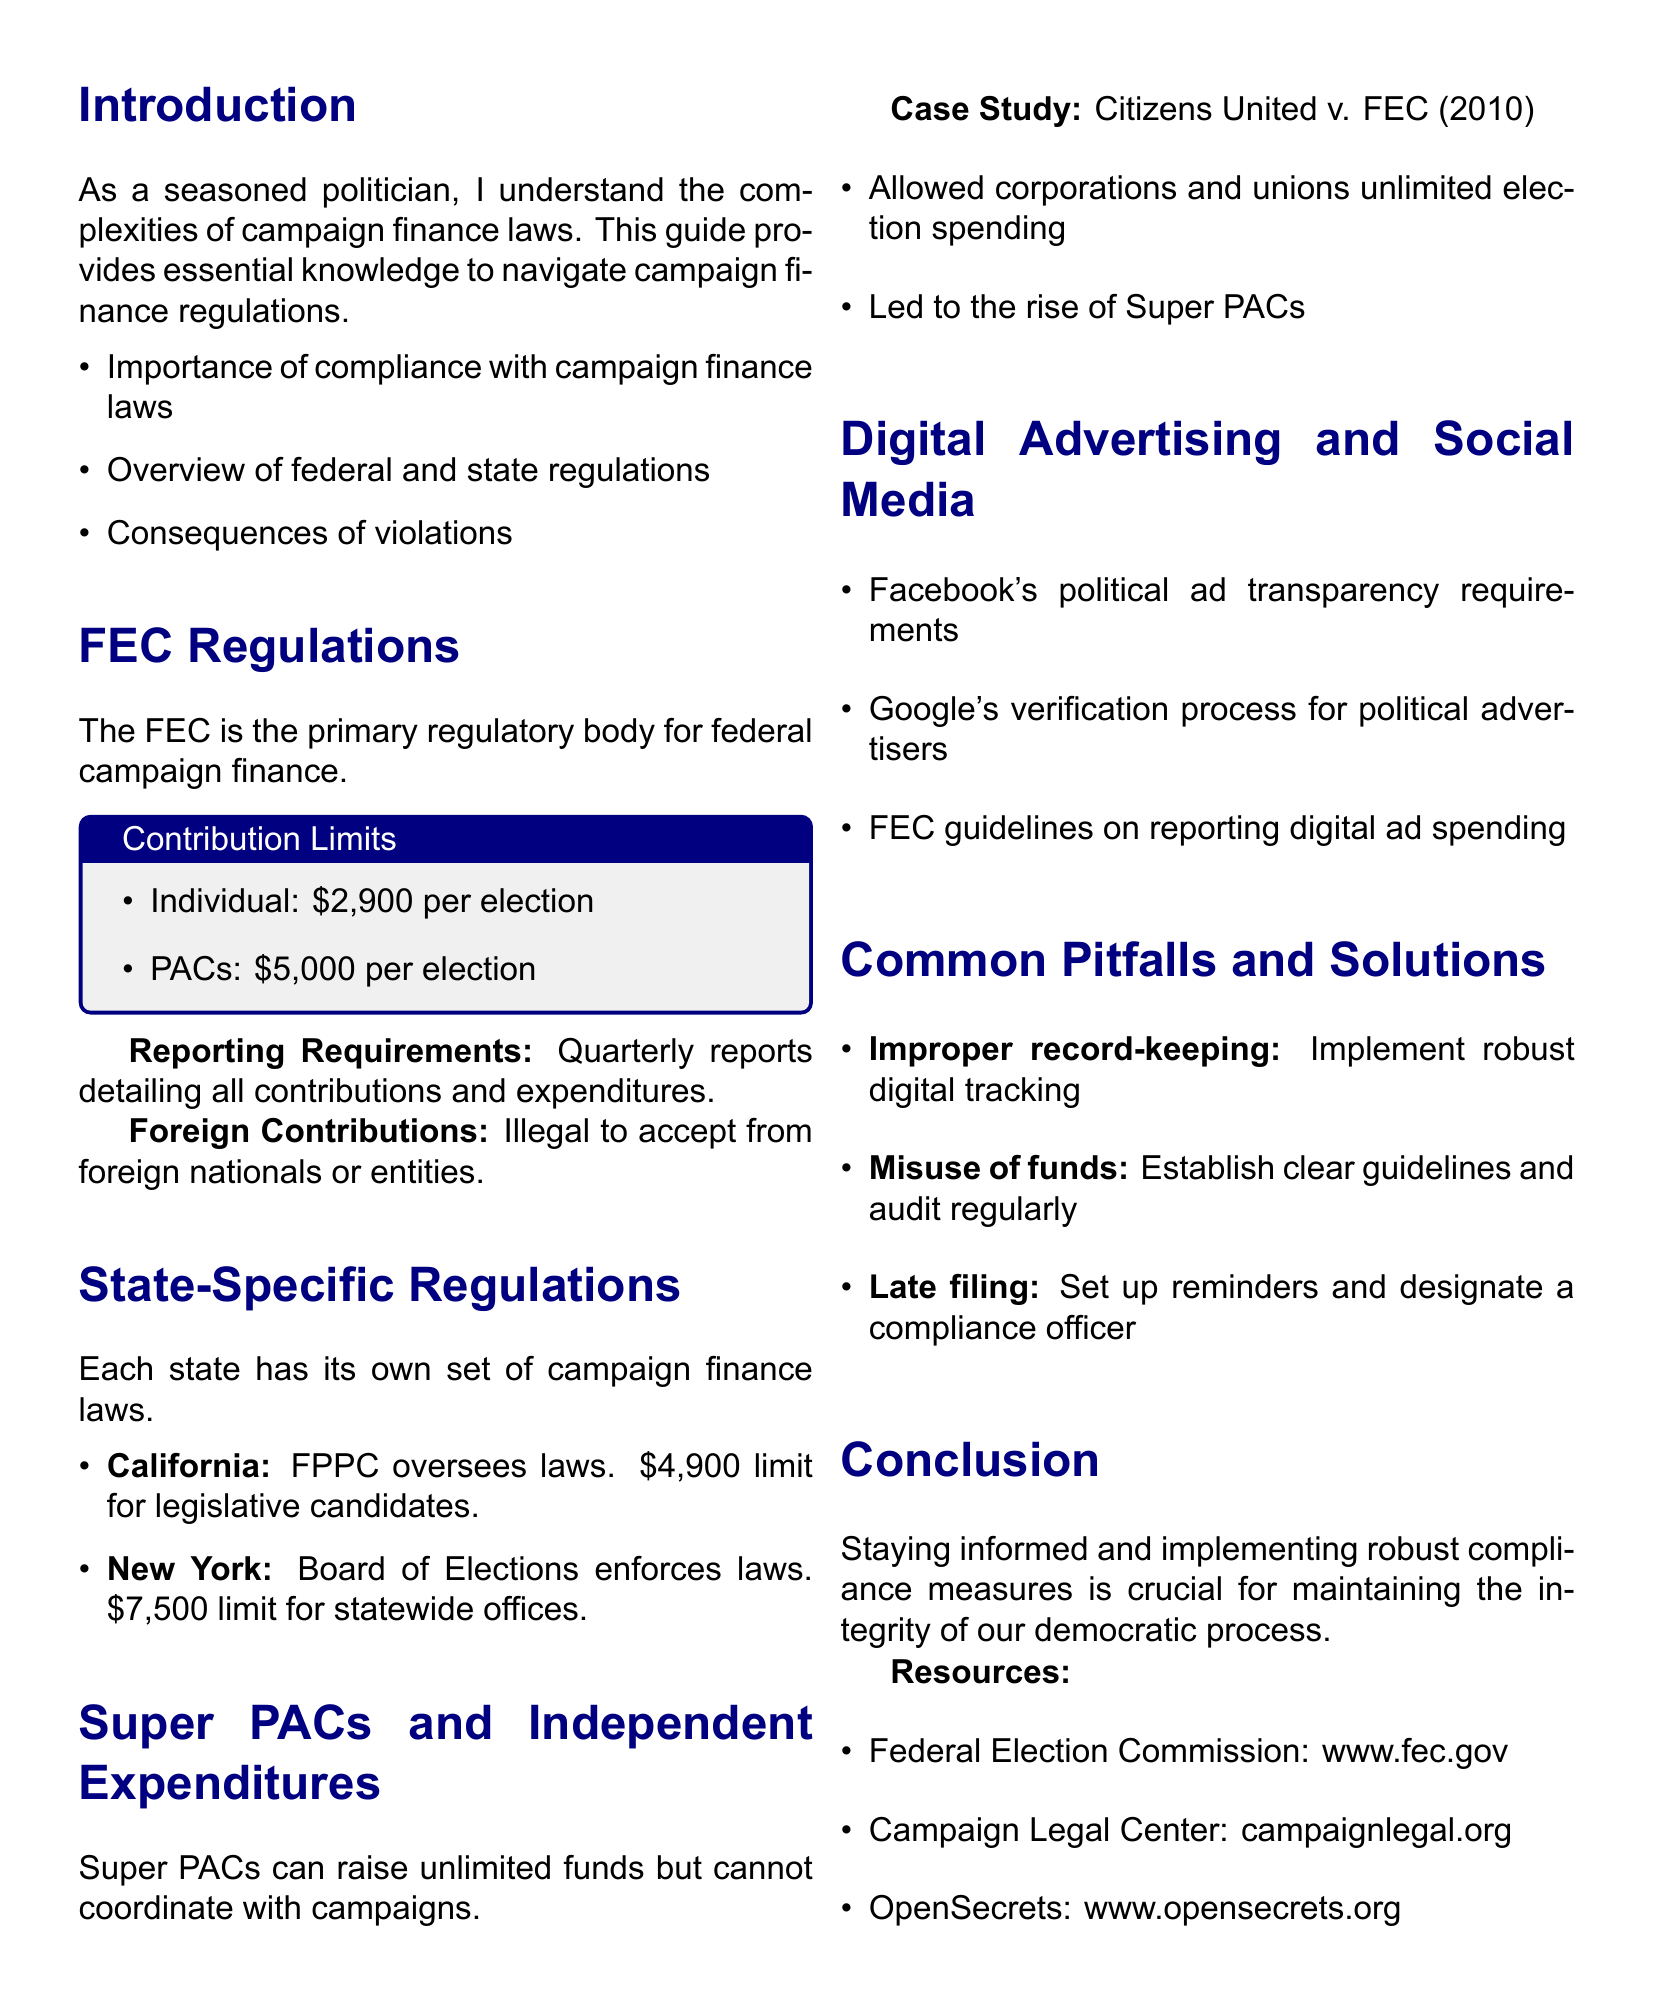what is the contribution limit for individuals to a federal candidate? The document states that individual contributions are limited to $2,900 per election to a federal candidate.
Answer: $2,900 which regulatory body oversees state campaign finance laws in California? The California Fair Political Practices Commission (FPPC) is responsible for overseeing state campaign finance laws.
Answer: FPPC what landmark case allowed corporations and unions to spend unlimited amounts on elections? The document refers to Citizens United v. FEC (2010) as the landmark case.
Answer: Citizens United v. FEC (2010) how often must quarterly reports be filed with the FEC? The document mentions that quarterly reports must detail all contributions and expenditures but does not specify the exact timing, indicating they are filed every quarter.
Answer: Quarterly what is the contribution limit for statewide offices in New York? According to the document, the contribution limit for statewide offices in New York is $7,500 for the election cycle.
Answer: $7,500 what is a common pitfall candidates face regarding record-keeping? The document identifies improper record-keeping as a frequent mistake candidates make.
Answer: Improper record-keeping how can candidates avoid the misuse of campaign funds? The document suggests establishing clear guidelines for campaign spending and regularly auditing expenses to prevent misuse.
Answer: Establish clear guidelines which social media platform has specific political ad transparency requirements? The document notes that Facebook has political ad transparency requirements.
Answer: Facebook what is essential for maintaining the integrity of the democratic process according to the conclusion? The conclusion emphasizes that staying informed and implementing robust compliance measures is crucial for maintaining integrity.
Answer: Staying informed and implementing robust compliance measures 